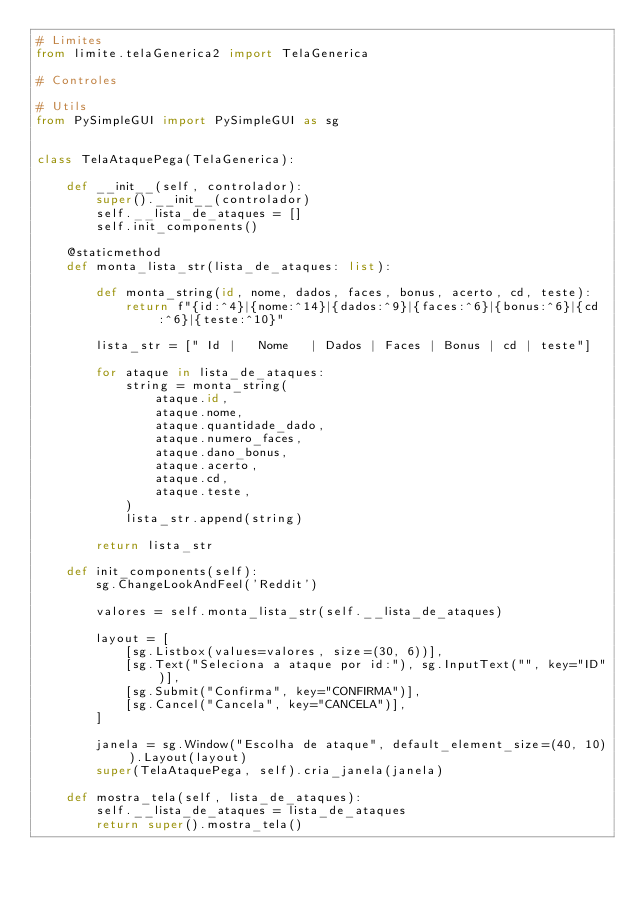Convert code to text. <code><loc_0><loc_0><loc_500><loc_500><_Python_># Limites
from limite.telaGenerica2 import TelaGenerica

# Controles

# Utils
from PySimpleGUI import PySimpleGUI as sg


class TelaAtaquePega(TelaGenerica):

    def __init__(self, controlador):
        super().__init__(controlador)
        self.__lista_de_ataques = []
        self.init_components()

    @staticmethod
    def monta_lista_str(lista_de_ataques: list):

        def monta_string(id, nome, dados, faces, bonus, acerto, cd, teste):
            return f"{id:^4}|{nome:^14}|{dados:^9}|{faces:^6}|{bonus:^6}|{cd:^6}|{teste:^10}"

        lista_str = [" Id |   Nome   | Dados | Faces | Bonus | cd | teste"]
        
        for ataque in lista_de_ataques:
            string = monta_string(
                ataque.id,
                ataque.nome,
                ataque.quantidade_dado,
                ataque.numero_faces,
                ataque.dano_bonus,
                ataque.acerto,
                ataque.cd,
                ataque.teste,
            )
            lista_str.append(string)

        return lista_str

    def init_components(self):
        sg.ChangeLookAndFeel('Reddit')

        valores = self.monta_lista_str(self.__lista_de_ataques)

        layout = [
            [sg.Listbox(values=valores, size=(30, 6))],
            [sg.Text("Seleciona a ataque por id:"), sg.InputText("", key="ID")],
            [sg.Submit("Confirma", key="CONFIRMA")],
            [sg.Cancel("Cancela", key="CANCELA")],
        ]

        janela = sg.Window("Escolha de ataque", default_element_size=(40, 10)).Layout(layout)
        super(TelaAtaquePega, self).cria_janela(janela)

    def mostra_tela(self, lista_de_ataques):
        self.__lista_de_ataques = lista_de_ataques
        return super().mostra_tela()
</code> 